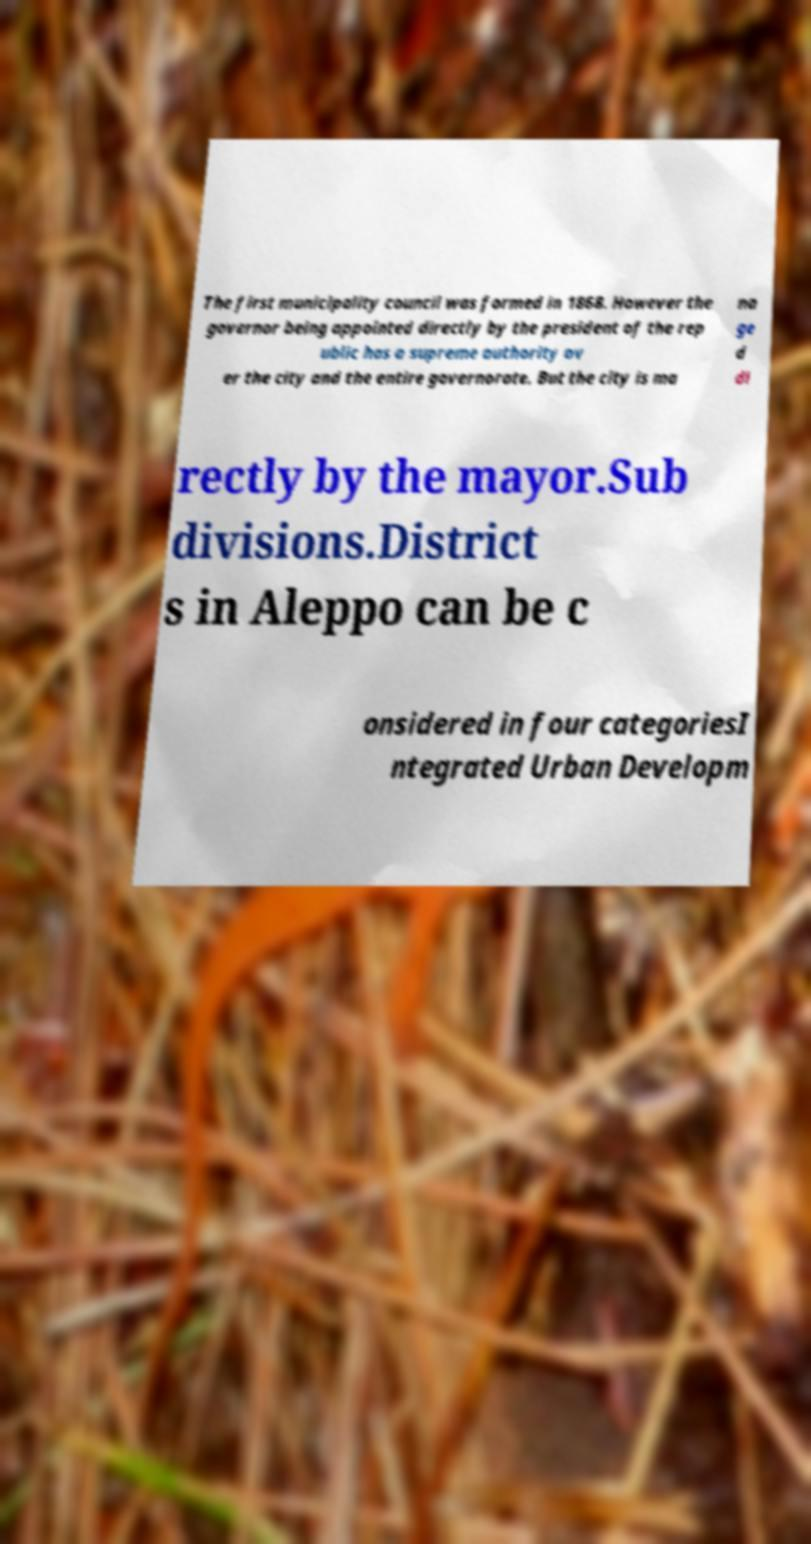Could you assist in decoding the text presented in this image and type it out clearly? The first municipality council was formed in 1868. However the governor being appointed directly by the president of the rep ublic has a supreme authority ov er the city and the entire governorate. But the city is ma na ge d di rectly by the mayor.Sub divisions.District s in Aleppo can be c onsidered in four categoriesI ntegrated Urban Developm 